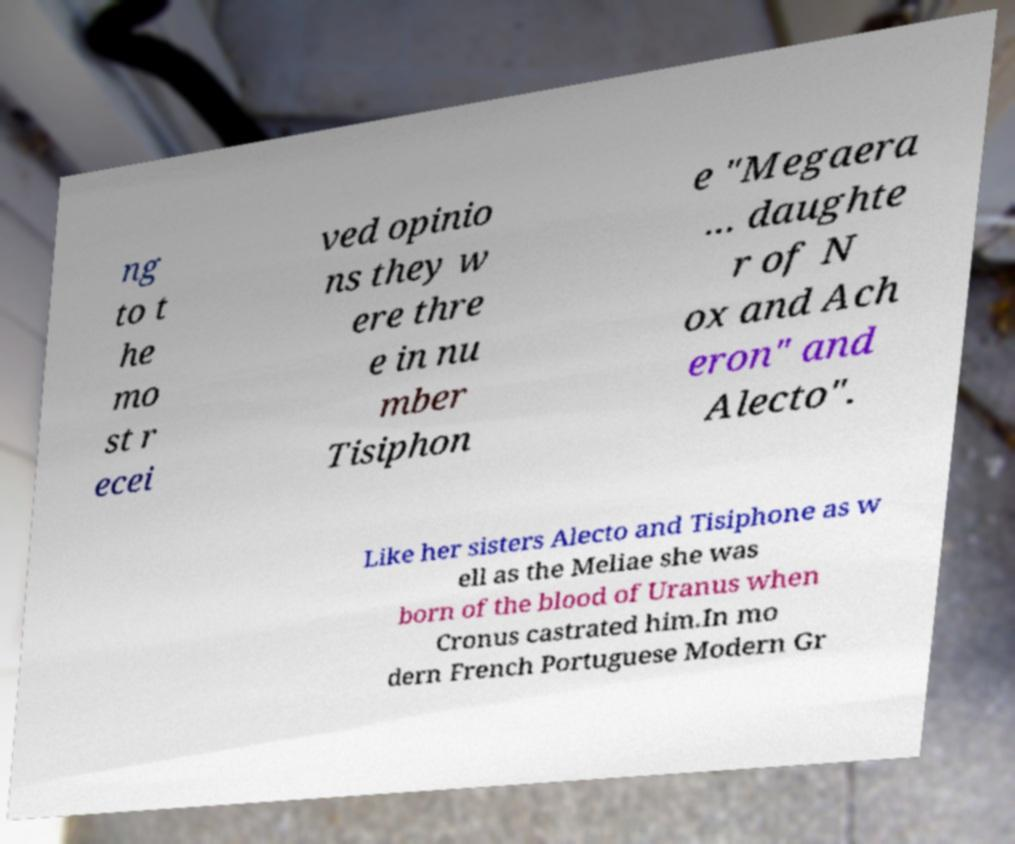I need the written content from this picture converted into text. Can you do that? ng to t he mo st r ecei ved opinio ns they w ere thre e in nu mber Tisiphon e "Megaera ... daughte r of N ox and Ach eron" and Alecto". Like her sisters Alecto and Tisiphone as w ell as the Meliae she was born of the blood of Uranus when Cronus castrated him.In mo dern French Portuguese Modern Gr 